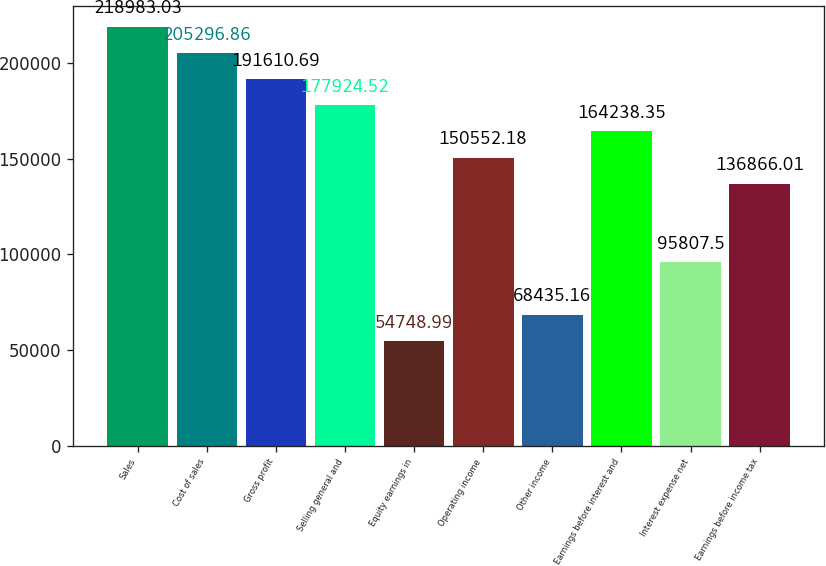Convert chart. <chart><loc_0><loc_0><loc_500><loc_500><bar_chart><fcel>Sales<fcel>Cost of sales<fcel>Gross profit<fcel>Selling general and<fcel>Equity earnings in<fcel>Operating income<fcel>Other income<fcel>Earnings before interest and<fcel>Interest expense net<fcel>Earnings before income tax<nl><fcel>218983<fcel>205297<fcel>191611<fcel>177925<fcel>54749<fcel>150552<fcel>68435.2<fcel>164238<fcel>95807.5<fcel>136866<nl></chart> 